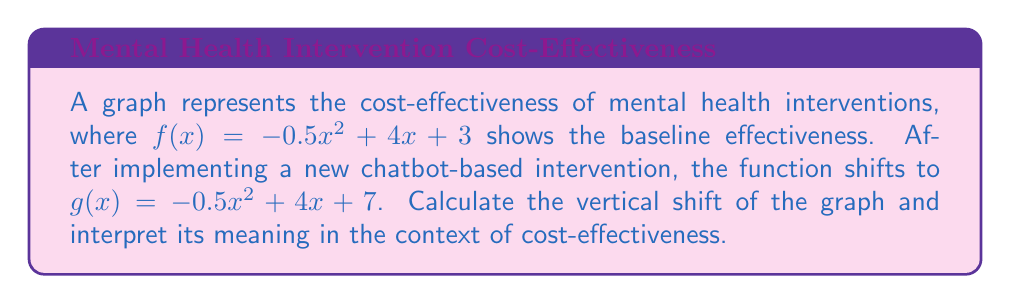Give your solution to this math problem. To find the vertical shift:

1) Compare the general forms of $f(x)$ and $g(x)$:
   $f(x) = -0.5x^2 + 4x + 3$
   $g(x) = -0.5x^2 + 4x + 7$

2) The vertical shift is the difference in the constant terms:
   $7 - 3 = 4$

3) Since the new function $g(x)$ has a larger constant term, the graph has shifted upward by 4 units.

4) In the context of cost-effectiveness:
   - The y-axis typically represents the effectiveness or benefit.
   - An upward shift means that for any given cost (x-value), the new intervention provides a higher benefit.
   - The magnitude of 4 units suggests a significant improvement in cost-effectiveness across all cost levels.

5) For policymakers, this indicates that the chatbot-based intervention has increased the overall cost-effectiveness of mental health interventions by a constant factor, regardless of the initial cost input.
Answer: 4 units upward 